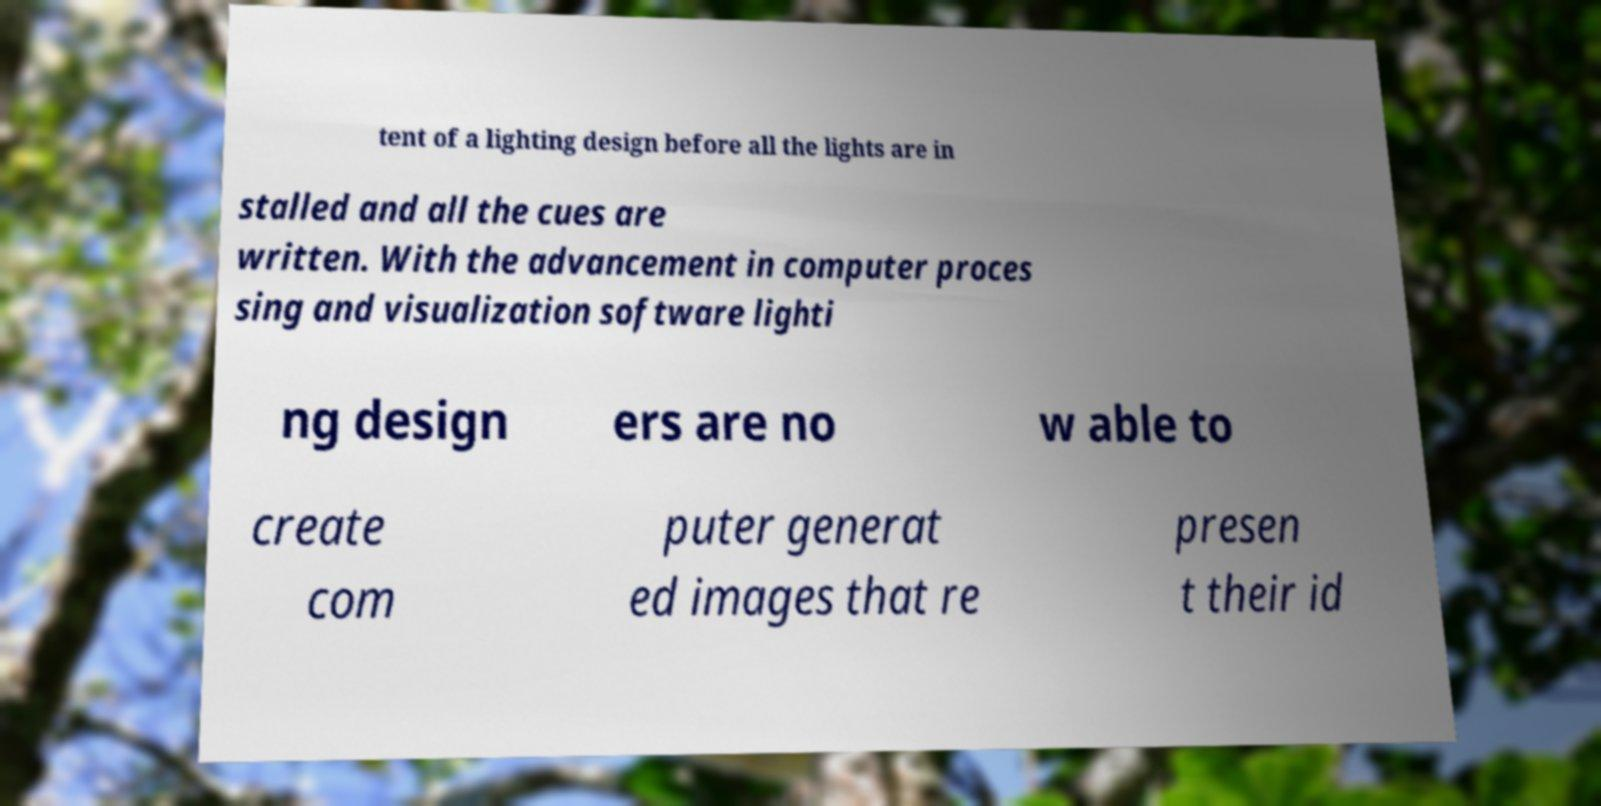What messages or text are displayed in this image? I need them in a readable, typed format. tent of a lighting design before all the lights are in stalled and all the cues are written. With the advancement in computer proces sing and visualization software lighti ng design ers are no w able to create com puter generat ed images that re presen t their id 